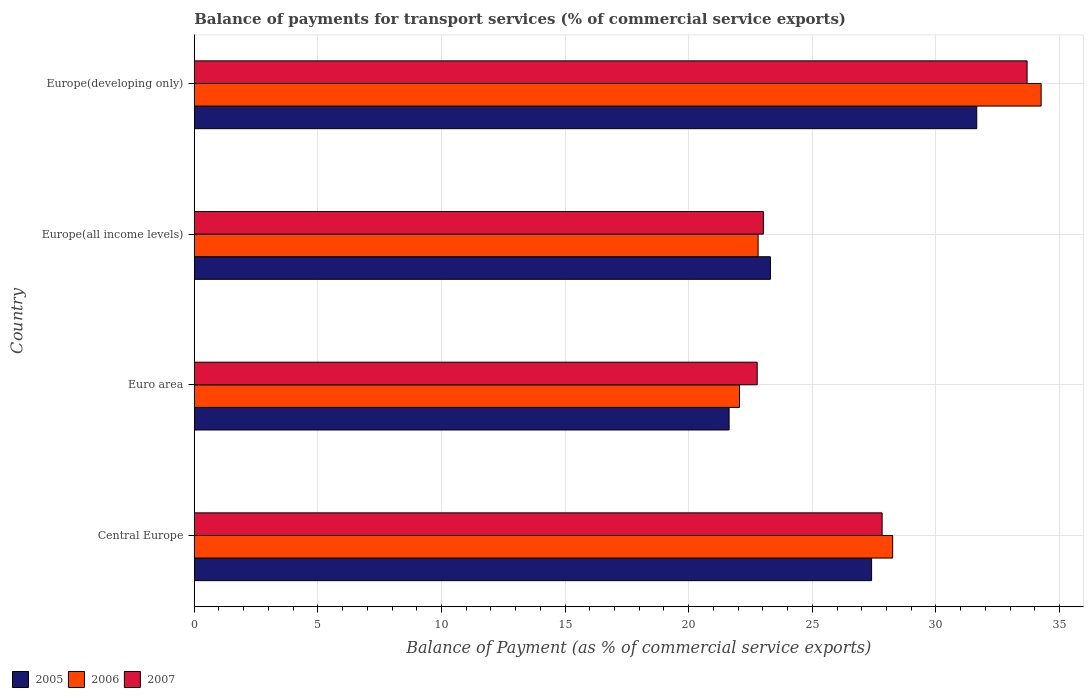Are the number of bars per tick equal to the number of legend labels?
Provide a short and direct response. Yes. Are the number of bars on each tick of the Y-axis equal?
Your answer should be compact. Yes. How many bars are there on the 4th tick from the top?
Your response must be concise. 3. What is the label of the 2nd group of bars from the top?
Your answer should be compact. Europe(all income levels). In how many cases, is the number of bars for a given country not equal to the number of legend labels?
Your answer should be very brief. 0. What is the balance of payments for transport services in 2007 in Europe(developing only)?
Your answer should be very brief. 33.69. Across all countries, what is the maximum balance of payments for transport services in 2007?
Offer a very short reply. 33.69. Across all countries, what is the minimum balance of payments for transport services in 2005?
Offer a very short reply. 21.64. In which country was the balance of payments for transport services in 2007 maximum?
Your response must be concise. Europe(developing only). What is the total balance of payments for transport services in 2005 in the graph?
Offer a terse response. 103.99. What is the difference between the balance of payments for transport services in 2007 in Euro area and that in Europe(developing only)?
Provide a short and direct response. -10.92. What is the difference between the balance of payments for transport services in 2006 in Europe(developing only) and the balance of payments for transport services in 2005 in Central Europe?
Your answer should be compact. 6.86. What is the average balance of payments for transport services in 2005 per country?
Your answer should be compact. 26. What is the difference between the balance of payments for transport services in 2007 and balance of payments for transport services in 2005 in Euro area?
Give a very brief answer. 1.14. What is the ratio of the balance of payments for transport services in 2005 in Euro area to that in Europe(developing only)?
Offer a very short reply. 0.68. Is the balance of payments for transport services in 2005 in Europe(all income levels) less than that in Europe(developing only)?
Provide a succinct answer. Yes. Is the difference between the balance of payments for transport services in 2007 in Central Europe and Europe(all income levels) greater than the difference between the balance of payments for transport services in 2005 in Central Europe and Europe(all income levels)?
Your answer should be compact. Yes. What is the difference between the highest and the second highest balance of payments for transport services in 2006?
Ensure brevity in your answer.  6.01. What is the difference between the highest and the lowest balance of payments for transport services in 2005?
Ensure brevity in your answer.  10.02. In how many countries, is the balance of payments for transport services in 2006 greater than the average balance of payments for transport services in 2006 taken over all countries?
Give a very brief answer. 2. What does the 1st bar from the top in Central Europe represents?
Your answer should be compact. 2007. How many bars are there?
Provide a succinct answer. 12. How many countries are there in the graph?
Make the answer very short. 4. Are the values on the major ticks of X-axis written in scientific E-notation?
Give a very brief answer. No. Does the graph contain any zero values?
Ensure brevity in your answer.  No. How are the legend labels stacked?
Provide a succinct answer. Horizontal. What is the title of the graph?
Offer a very short reply. Balance of payments for transport services (% of commercial service exports). Does "2006" appear as one of the legend labels in the graph?
Keep it short and to the point. Yes. What is the label or title of the X-axis?
Ensure brevity in your answer.  Balance of Payment (as % of commercial service exports). What is the label or title of the Y-axis?
Your answer should be very brief. Country. What is the Balance of Payment (as % of commercial service exports) of 2005 in Central Europe?
Offer a terse response. 27.4. What is the Balance of Payment (as % of commercial service exports) in 2006 in Central Europe?
Ensure brevity in your answer.  28.25. What is the Balance of Payment (as % of commercial service exports) of 2007 in Central Europe?
Offer a very short reply. 27.82. What is the Balance of Payment (as % of commercial service exports) of 2005 in Euro area?
Provide a succinct answer. 21.64. What is the Balance of Payment (as % of commercial service exports) of 2006 in Euro area?
Your answer should be very brief. 22.06. What is the Balance of Payment (as % of commercial service exports) in 2007 in Euro area?
Provide a succinct answer. 22.77. What is the Balance of Payment (as % of commercial service exports) of 2005 in Europe(all income levels)?
Provide a short and direct response. 23.31. What is the Balance of Payment (as % of commercial service exports) of 2006 in Europe(all income levels)?
Your response must be concise. 22.81. What is the Balance of Payment (as % of commercial service exports) in 2007 in Europe(all income levels)?
Your response must be concise. 23.02. What is the Balance of Payment (as % of commercial service exports) of 2005 in Europe(developing only)?
Your answer should be compact. 31.65. What is the Balance of Payment (as % of commercial service exports) of 2006 in Europe(developing only)?
Offer a very short reply. 34.26. What is the Balance of Payment (as % of commercial service exports) of 2007 in Europe(developing only)?
Provide a succinct answer. 33.69. Across all countries, what is the maximum Balance of Payment (as % of commercial service exports) of 2005?
Ensure brevity in your answer.  31.65. Across all countries, what is the maximum Balance of Payment (as % of commercial service exports) in 2006?
Make the answer very short. 34.26. Across all countries, what is the maximum Balance of Payment (as % of commercial service exports) in 2007?
Provide a short and direct response. 33.69. Across all countries, what is the minimum Balance of Payment (as % of commercial service exports) of 2005?
Your answer should be very brief. 21.64. Across all countries, what is the minimum Balance of Payment (as % of commercial service exports) of 2006?
Keep it short and to the point. 22.06. Across all countries, what is the minimum Balance of Payment (as % of commercial service exports) of 2007?
Offer a very short reply. 22.77. What is the total Balance of Payment (as % of commercial service exports) in 2005 in the graph?
Offer a very short reply. 103.99. What is the total Balance of Payment (as % of commercial service exports) of 2006 in the graph?
Ensure brevity in your answer.  107.37. What is the total Balance of Payment (as % of commercial service exports) of 2007 in the graph?
Your answer should be very brief. 107.3. What is the difference between the Balance of Payment (as % of commercial service exports) of 2005 in Central Europe and that in Euro area?
Ensure brevity in your answer.  5.76. What is the difference between the Balance of Payment (as % of commercial service exports) in 2006 in Central Europe and that in Euro area?
Keep it short and to the point. 6.2. What is the difference between the Balance of Payment (as % of commercial service exports) of 2007 in Central Europe and that in Euro area?
Your answer should be compact. 5.05. What is the difference between the Balance of Payment (as % of commercial service exports) of 2005 in Central Europe and that in Europe(all income levels)?
Provide a short and direct response. 4.09. What is the difference between the Balance of Payment (as % of commercial service exports) of 2006 in Central Europe and that in Europe(all income levels)?
Keep it short and to the point. 5.44. What is the difference between the Balance of Payment (as % of commercial service exports) of 2007 in Central Europe and that in Europe(all income levels)?
Your answer should be compact. 4.8. What is the difference between the Balance of Payment (as % of commercial service exports) of 2005 in Central Europe and that in Europe(developing only)?
Ensure brevity in your answer.  -4.25. What is the difference between the Balance of Payment (as % of commercial service exports) of 2006 in Central Europe and that in Europe(developing only)?
Keep it short and to the point. -6.01. What is the difference between the Balance of Payment (as % of commercial service exports) of 2007 in Central Europe and that in Europe(developing only)?
Keep it short and to the point. -5.86. What is the difference between the Balance of Payment (as % of commercial service exports) of 2005 in Euro area and that in Europe(all income levels)?
Keep it short and to the point. -1.67. What is the difference between the Balance of Payment (as % of commercial service exports) of 2006 in Euro area and that in Europe(all income levels)?
Your answer should be very brief. -0.75. What is the difference between the Balance of Payment (as % of commercial service exports) of 2007 in Euro area and that in Europe(all income levels)?
Keep it short and to the point. -0.25. What is the difference between the Balance of Payment (as % of commercial service exports) of 2005 in Euro area and that in Europe(developing only)?
Make the answer very short. -10.02. What is the difference between the Balance of Payment (as % of commercial service exports) in 2006 in Euro area and that in Europe(developing only)?
Ensure brevity in your answer.  -12.2. What is the difference between the Balance of Payment (as % of commercial service exports) in 2007 in Euro area and that in Europe(developing only)?
Make the answer very short. -10.92. What is the difference between the Balance of Payment (as % of commercial service exports) of 2005 in Europe(all income levels) and that in Europe(developing only)?
Make the answer very short. -8.35. What is the difference between the Balance of Payment (as % of commercial service exports) in 2006 in Europe(all income levels) and that in Europe(developing only)?
Ensure brevity in your answer.  -11.45. What is the difference between the Balance of Payment (as % of commercial service exports) of 2007 in Europe(all income levels) and that in Europe(developing only)?
Offer a terse response. -10.67. What is the difference between the Balance of Payment (as % of commercial service exports) of 2005 in Central Europe and the Balance of Payment (as % of commercial service exports) of 2006 in Euro area?
Ensure brevity in your answer.  5.34. What is the difference between the Balance of Payment (as % of commercial service exports) of 2005 in Central Europe and the Balance of Payment (as % of commercial service exports) of 2007 in Euro area?
Your answer should be compact. 4.63. What is the difference between the Balance of Payment (as % of commercial service exports) of 2006 in Central Europe and the Balance of Payment (as % of commercial service exports) of 2007 in Euro area?
Offer a terse response. 5.48. What is the difference between the Balance of Payment (as % of commercial service exports) of 2005 in Central Europe and the Balance of Payment (as % of commercial service exports) of 2006 in Europe(all income levels)?
Offer a terse response. 4.59. What is the difference between the Balance of Payment (as % of commercial service exports) in 2005 in Central Europe and the Balance of Payment (as % of commercial service exports) in 2007 in Europe(all income levels)?
Provide a short and direct response. 4.38. What is the difference between the Balance of Payment (as % of commercial service exports) in 2006 in Central Europe and the Balance of Payment (as % of commercial service exports) in 2007 in Europe(all income levels)?
Offer a terse response. 5.23. What is the difference between the Balance of Payment (as % of commercial service exports) in 2005 in Central Europe and the Balance of Payment (as % of commercial service exports) in 2006 in Europe(developing only)?
Your answer should be compact. -6.86. What is the difference between the Balance of Payment (as % of commercial service exports) in 2005 in Central Europe and the Balance of Payment (as % of commercial service exports) in 2007 in Europe(developing only)?
Offer a very short reply. -6.29. What is the difference between the Balance of Payment (as % of commercial service exports) in 2006 in Central Europe and the Balance of Payment (as % of commercial service exports) in 2007 in Europe(developing only)?
Your answer should be compact. -5.44. What is the difference between the Balance of Payment (as % of commercial service exports) in 2005 in Euro area and the Balance of Payment (as % of commercial service exports) in 2006 in Europe(all income levels)?
Keep it short and to the point. -1.17. What is the difference between the Balance of Payment (as % of commercial service exports) in 2005 in Euro area and the Balance of Payment (as % of commercial service exports) in 2007 in Europe(all income levels)?
Make the answer very short. -1.39. What is the difference between the Balance of Payment (as % of commercial service exports) of 2006 in Euro area and the Balance of Payment (as % of commercial service exports) of 2007 in Europe(all income levels)?
Offer a terse response. -0.97. What is the difference between the Balance of Payment (as % of commercial service exports) of 2005 in Euro area and the Balance of Payment (as % of commercial service exports) of 2006 in Europe(developing only)?
Make the answer very short. -12.62. What is the difference between the Balance of Payment (as % of commercial service exports) in 2005 in Euro area and the Balance of Payment (as % of commercial service exports) in 2007 in Europe(developing only)?
Ensure brevity in your answer.  -12.05. What is the difference between the Balance of Payment (as % of commercial service exports) of 2006 in Euro area and the Balance of Payment (as % of commercial service exports) of 2007 in Europe(developing only)?
Keep it short and to the point. -11.63. What is the difference between the Balance of Payment (as % of commercial service exports) in 2005 in Europe(all income levels) and the Balance of Payment (as % of commercial service exports) in 2006 in Europe(developing only)?
Ensure brevity in your answer.  -10.95. What is the difference between the Balance of Payment (as % of commercial service exports) of 2005 in Europe(all income levels) and the Balance of Payment (as % of commercial service exports) of 2007 in Europe(developing only)?
Your response must be concise. -10.38. What is the difference between the Balance of Payment (as % of commercial service exports) in 2006 in Europe(all income levels) and the Balance of Payment (as % of commercial service exports) in 2007 in Europe(developing only)?
Your answer should be very brief. -10.88. What is the average Balance of Payment (as % of commercial service exports) of 2005 per country?
Provide a succinct answer. 26. What is the average Balance of Payment (as % of commercial service exports) of 2006 per country?
Make the answer very short. 26.84. What is the average Balance of Payment (as % of commercial service exports) in 2007 per country?
Make the answer very short. 26.83. What is the difference between the Balance of Payment (as % of commercial service exports) of 2005 and Balance of Payment (as % of commercial service exports) of 2006 in Central Europe?
Provide a succinct answer. -0.85. What is the difference between the Balance of Payment (as % of commercial service exports) in 2005 and Balance of Payment (as % of commercial service exports) in 2007 in Central Europe?
Provide a succinct answer. -0.43. What is the difference between the Balance of Payment (as % of commercial service exports) of 2006 and Balance of Payment (as % of commercial service exports) of 2007 in Central Europe?
Provide a short and direct response. 0.43. What is the difference between the Balance of Payment (as % of commercial service exports) in 2005 and Balance of Payment (as % of commercial service exports) in 2006 in Euro area?
Make the answer very short. -0.42. What is the difference between the Balance of Payment (as % of commercial service exports) in 2005 and Balance of Payment (as % of commercial service exports) in 2007 in Euro area?
Make the answer very short. -1.14. What is the difference between the Balance of Payment (as % of commercial service exports) in 2006 and Balance of Payment (as % of commercial service exports) in 2007 in Euro area?
Provide a succinct answer. -0.72. What is the difference between the Balance of Payment (as % of commercial service exports) in 2005 and Balance of Payment (as % of commercial service exports) in 2006 in Europe(all income levels)?
Provide a short and direct response. 0.5. What is the difference between the Balance of Payment (as % of commercial service exports) in 2005 and Balance of Payment (as % of commercial service exports) in 2007 in Europe(all income levels)?
Make the answer very short. 0.29. What is the difference between the Balance of Payment (as % of commercial service exports) of 2006 and Balance of Payment (as % of commercial service exports) of 2007 in Europe(all income levels)?
Your response must be concise. -0.21. What is the difference between the Balance of Payment (as % of commercial service exports) in 2005 and Balance of Payment (as % of commercial service exports) in 2006 in Europe(developing only)?
Provide a succinct answer. -2.6. What is the difference between the Balance of Payment (as % of commercial service exports) of 2005 and Balance of Payment (as % of commercial service exports) of 2007 in Europe(developing only)?
Offer a terse response. -2.04. What is the difference between the Balance of Payment (as % of commercial service exports) of 2006 and Balance of Payment (as % of commercial service exports) of 2007 in Europe(developing only)?
Provide a succinct answer. 0.57. What is the ratio of the Balance of Payment (as % of commercial service exports) in 2005 in Central Europe to that in Euro area?
Offer a terse response. 1.27. What is the ratio of the Balance of Payment (as % of commercial service exports) of 2006 in Central Europe to that in Euro area?
Make the answer very short. 1.28. What is the ratio of the Balance of Payment (as % of commercial service exports) of 2007 in Central Europe to that in Euro area?
Provide a succinct answer. 1.22. What is the ratio of the Balance of Payment (as % of commercial service exports) of 2005 in Central Europe to that in Europe(all income levels)?
Offer a very short reply. 1.18. What is the ratio of the Balance of Payment (as % of commercial service exports) of 2006 in Central Europe to that in Europe(all income levels)?
Provide a succinct answer. 1.24. What is the ratio of the Balance of Payment (as % of commercial service exports) in 2007 in Central Europe to that in Europe(all income levels)?
Your answer should be compact. 1.21. What is the ratio of the Balance of Payment (as % of commercial service exports) of 2005 in Central Europe to that in Europe(developing only)?
Your answer should be compact. 0.87. What is the ratio of the Balance of Payment (as % of commercial service exports) in 2006 in Central Europe to that in Europe(developing only)?
Provide a succinct answer. 0.82. What is the ratio of the Balance of Payment (as % of commercial service exports) of 2007 in Central Europe to that in Europe(developing only)?
Offer a terse response. 0.83. What is the ratio of the Balance of Payment (as % of commercial service exports) of 2005 in Euro area to that in Europe(all income levels)?
Make the answer very short. 0.93. What is the ratio of the Balance of Payment (as % of commercial service exports) in 2006 in Euro area to that in Europe(all income levels)?
Give a very brief answer. 0.97. What is the ratio of the Balance of Payment (as % of commercial service exports) of 2005 in Euro area to that in Europe(developing only)?
Offer a terse response. 0.68. What is the ratio of the Balance of Payment (as % of commercial service exports) of 2006 in Euro area to that in Europe(developing only)?
Your response must be concise. 0.64. What is the ratio of the Balance of Payment (as % of commercial service exports) of 2007 in Euro area to that in Europe(developing only)?
Ensure brevity in your answer.  0.68. What is the ratio of the Balance of Payment (as % of commercial service exports) in 2005 in Europe(all income levels) to that in Europe(developing only)?
Keep it short and to the point. 0.74. What is the ratio of the Balance of Payment (as % of commercial service exports) in 2006 in Europe(all income levels) to that in Europe(developing only)?
Offer a terse response. 0.67. What is the ratio of the Balance of Payment (as % of commercial service exports) of 2007 in Europe(all income levels) to that in Europe(developing only)?
Give a very brief answer. 0.68. What is the difference between the highest and the second highest Balance of Payment (as % of commercial service exports) of 2005?
Make the answer very short. 4.25. What is the difference between the highest and the second highest Balance of Payment (as % of commercial service exports) in 2006?
Ensure brevity in your answer.  6.01. What is the difference between the highest and the second highest Balance of Payment (as % of commercial service exports) in 2007?
Offer a very short reply. 5.86. What is the difference between the highest and the lowest Balance of Payment (as % of commercial service exports) in 2005?
Give a very brief answer. 10.02. What is the difference between the highest and the lowest Balance of Payment (as % of commercial service exports) in 2006?
Provide a short and direct response. 12.2. What is the difference between the highest and the lowest Balance of Payment (as % of commercial service exports) in 2007?
Offer a terse response. 10.92. 